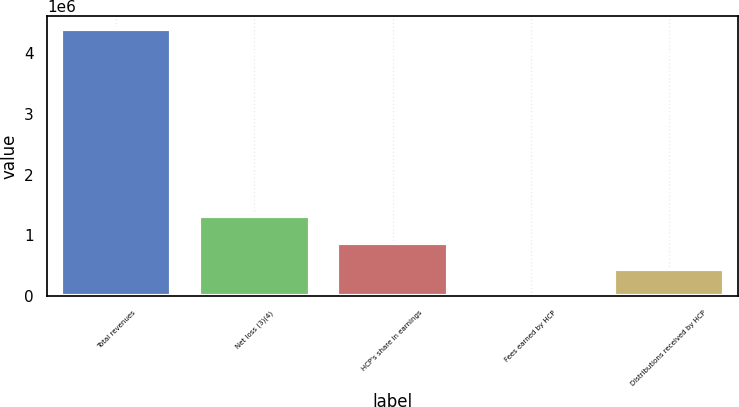<chart> <loc_0><loc_0><loc_500><loc_500><bar_chart><fcel>Total revenues<fcel>Net loss (3)(4)<fcel>HCP's share in earnings<fcel>Fees earned by HCP<fcel>Distributions received by HCP<nl><fcel>4.38838e+06<fcel>1.31796e+06<fcel>879334<fcel>2073<fcel>440703<nl></chart> 